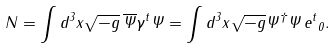Convert formula to latex. <formula><loc_0><loc_0><loc_500><loc_500>N = \int d ^ { 3 } x \sqrt { - g } \, \overline { \Psi } \gamma ^ { t } \Psi = \int d ^ { 3 } x \sqrt { - g } { \Psi } ^ { \dagger } \Psi \, { e ^ { t } } _ { 0 } .</formula> 